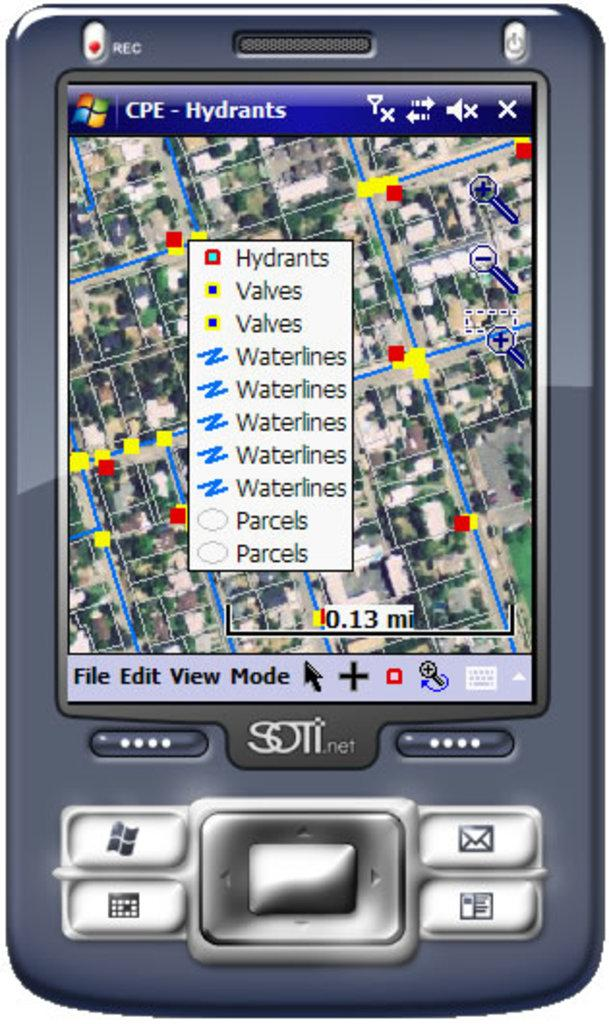What type of image is being described? The image is graphical. What object is depicted in the image? There is a mobile phone in the image. What feature of the mobile phone is mentioned in the facts? The mobile phone has buttons at the bottom. What type of current is flowing through the mobile phone in the image? There is no information about any current flowing through the mobile phone in the image. --- 